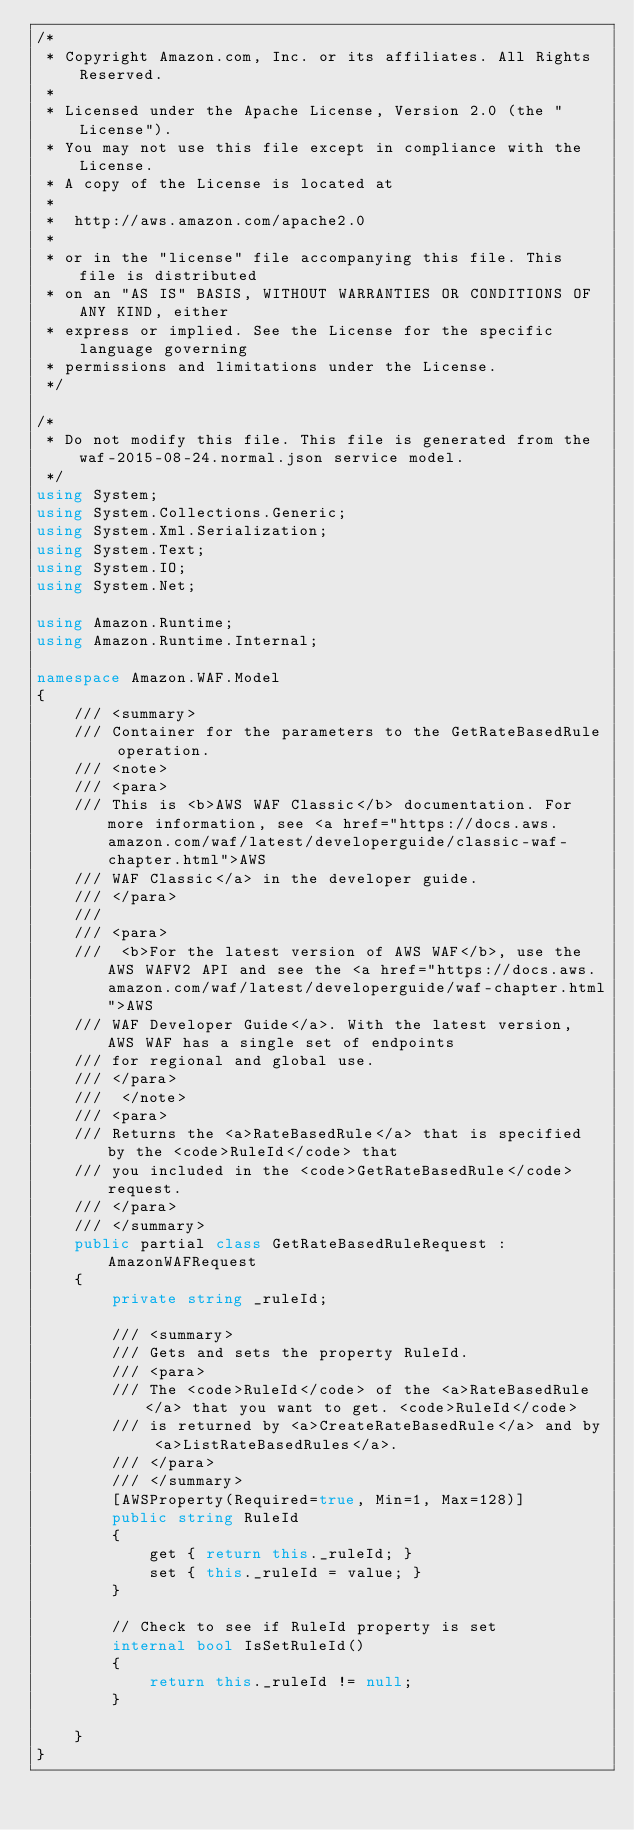<code> <loc_0><loc_0><loc_500><loc_500><_C#_>/*
 * Copyright Amazon.com, Inc. or its affiliates. All Rights Reserved.
 * 
 * Licensed under the Apache License, Version 2.0 (the "License").
 * You may not use this file except in compliance with the License.
 * A copy of the License is located at
 * 
 *  http://aws.amazon.com/apache2.0
 * 
 * or in the "license" file accompanying this file. This file is distributed
 * on an "AS IS" BASIS, WITHOUT WARRANTIES OR CONDITIONS OF ANY KIND, either
 * express or implied. See the License for the specific language governing
 * permissions and limitations under the License.
 */

/*
 * Do not modify this file. This file is generated from the waf-2015-08-24.normal.json service model.
 */
using System;
using System.Collections.Generic;
using System.Xml.Serialization;
using System.Text;
using System.IO;
using System.Net;

using Amazon.Runtime;
using Amazon.Runtime.Internal;

namespace Amazon.WAF.Model
{
    /// <summary>
    /// Container for the parameters to the GetRateBasedRule operation.
    /// <note> 
    /// <para>
    /// This is <b>AWS WAF Classic</b> documentation. For more information, see <a href="https://docs.aws.amazon.com/waf/latest/developerguide/classic-waf-chapter.html">AWS
    /// WAF Classic</a> in the developer guide.
    /// </para>
    ///  
    /// <para>
    ///  <b>For the latest version of AWS WAF</b>, use the AWS WAFV2 API and see the <a href="https://docs.aws.amazon.com/waf/latest/developerguide/waf-chapter.html">AWS
    /// WAF Developer Guide</a>. With the latest version, AWS WAF has a single set of endpoints
    /// for regional and global use. 
    /// </para>
    ///  </note> 
    /// <para>
    /// Returns the <a>RateBasedRule</a> that is specified by the <code>RuleId</code> that
    /// you included in the <code>GetRateBasedRule</code> request.
    /// </para>
    /// </summary>
    public partial class GetRateBasedRuleRequest : AmazonWAFRequest
    {
        private string _ruleId;

        /// <summary>
        /// Gets and sets the property RuleId. 
        /// <para>
        /// The <code>RuleId</code> of the <a>RateBasedRule</a> that you want to get. <code>RuleId</code>
        /// is returned by <a>CreateRateBasedRule</a> and by <a>ListRateBasedRules</a>.
        /// </para>
        /// </summary>
        [AWSProperty(Required=true, Min=1, Max=128)]
        public string RuleId
        {
            get { return this._ruleId; }
            set { this._ruleId = value; }
        }

        // Check to see if RuleId property is set
        internal bool IsSetRuleId()
        {
            return this._ruleId != null;
        }

    }
}</code> 